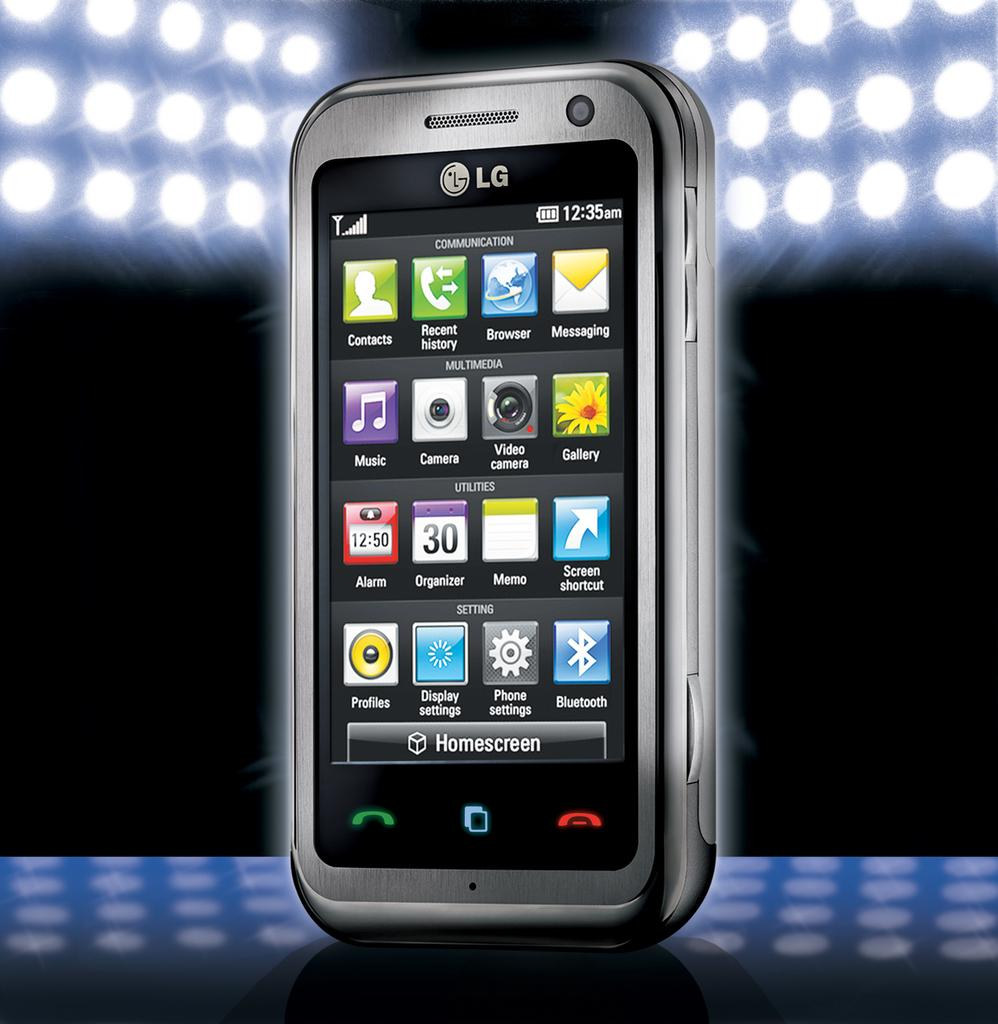<image>
Present a compact description of the photo's key features. An LG cell phone displaying the Homescreen and multiple icons. 